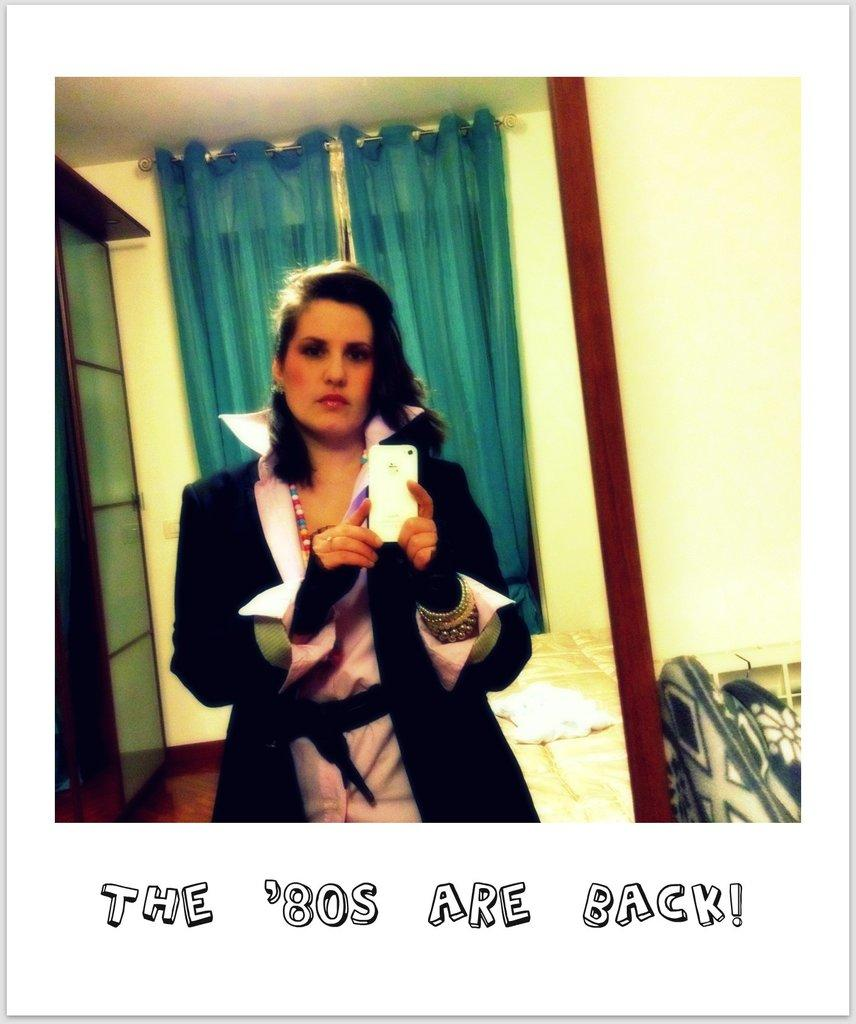Who is present in the image? There is a woman in the image. What is the woman doing in the image? The woman is standing in the image. What is the woman wearing in the image? The woman is wearing clothes, a finger ring, and a neck chain in the image. What object is the woman holding in her hand? The woman is holding a mobile phone in her hand in the image. What type of government is depicted in the image? There is no depiction of a government in the image; it features a woman standing and holding a mobile phone. 